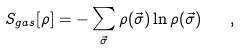Convert formula to latex. <formula><loc_0><loc_0><loc_500><loc_500>S _ { g a s } [ \rho ] = - \sum _ { \vec { \sigma } } \rho ( \vec { \sigma } ) \ln \rho ( \vec { \sigma } ) \quad ,</formula> 